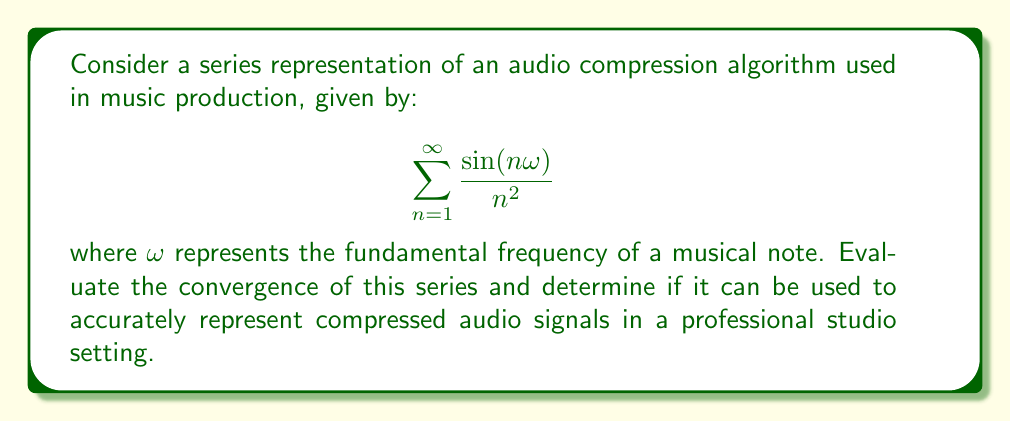Teach me how to tackle this problem. To evaluate the convergence of this series, we'll use the following steps:

1) First, let's consider the general term of the series:

   $$a_n = \frac{\sin(n\omega)}{n^2}$$

2) We know that $|\sin(n\omega)| \leq 1$ for all $n$ and $\omega$. Therefore:

   $$|a_n| = \left|\frac{\sin(n\omega)}{n^2}\right| \leq \frac{1}{n^2}$$

3) Now, we can compare this series to the p-series $\sum \frac{1}{n^p}$ with $p=2$:

   $$\sum_{n=1}^{\infty} |a_n| \leq \sum_{n=1}^{\infty} \frac{1}{n^2}$$

4) We know that the p-series converges for $p > 1$, and in this case, $p = 2 > 1$.

5) By the comparison test, since $\sum \frac{1}{n^2}$ converges, our original series also converges absolutely.

6) Moreover, we can identify this as a Dirichlet series, which is known to converge for all real $\omega$ when the power of $n$ in the denominator is greater than 1.

7) In the context of audio compression, this convergence implies that the series can represent a compressed audio signal with arbitrary precision by including more terms. Each term can be thought of as a harmonic component of the signal.

8) In a professional studio setting, this means that the algorithm can provide a high-quality compressed representation of audio signals, allowing for efficient storage and transmission while maintaining fidelity to the original sound.

9) The rate of convergence (determined by the $n^2$ denominator) suggests that relatively few terms may be needed to achieve a good approximation, which is beneficial for real-time processing in a studio environment.
Answer: The series $\sum_{n=1}^{\infty} \frac{\sin(n\omega)}{n^2}$ converges absolutely for all real values of $\omega$. It can be effectively used to represent compressed audio signals in a professional studio setting, providing a balance between compression efficiency and signal fidelity. 